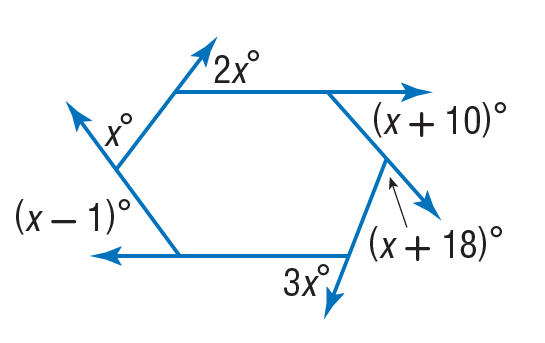Question: Find the value of x in the diagram.
Choices:
A. 36
B. 37
C. 38
D. 74
Answer with the letter. Answer: B 